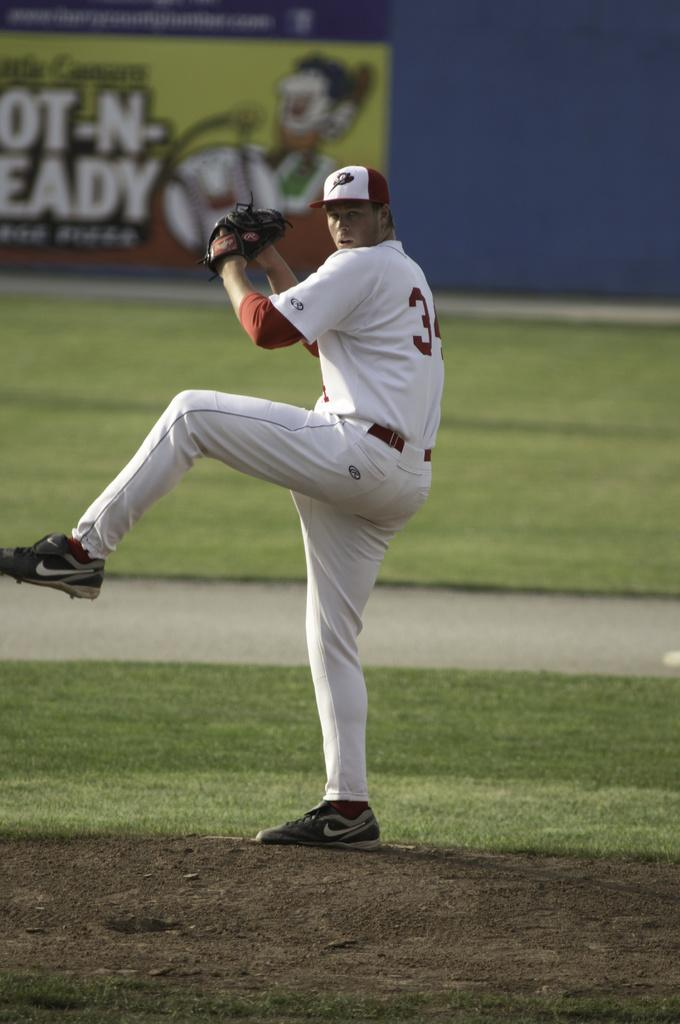<image>
Share a concise interpretation of the image provided. Only the number 3 is visible on the pitchers uniform. 